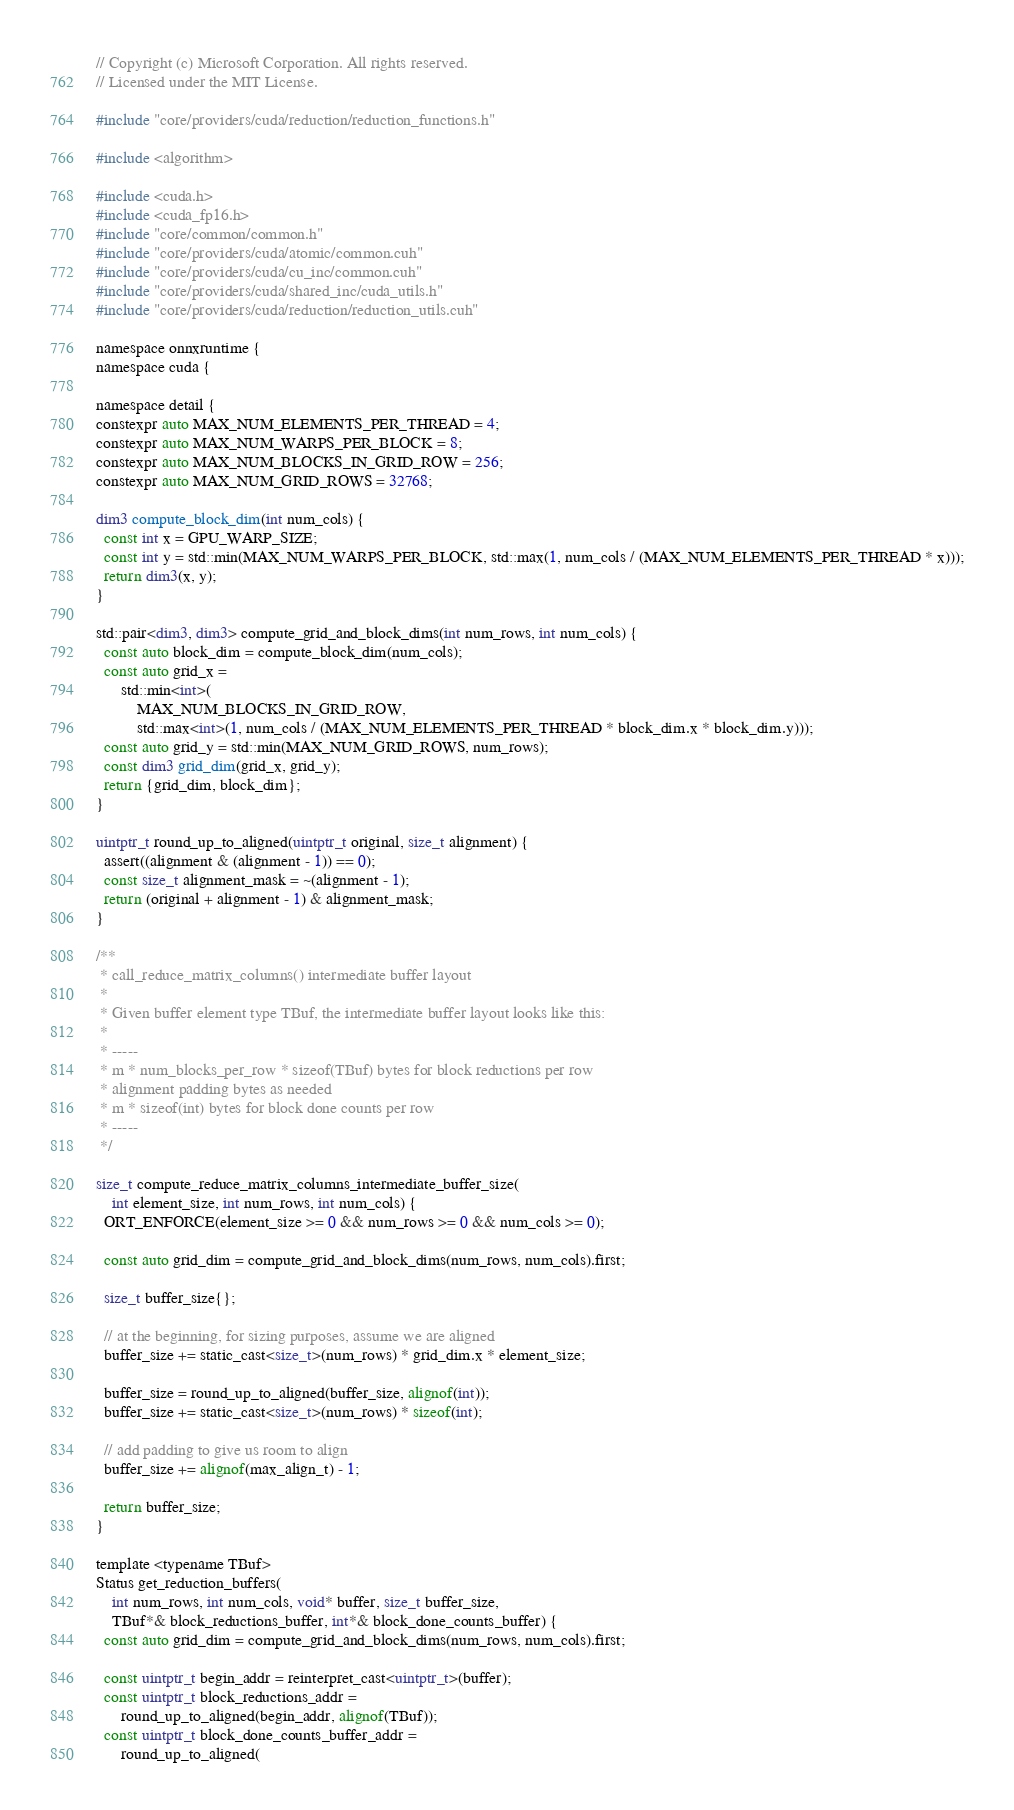Convert code to text. <code><loc_0><loc_0><loc_500><loc_500><_Cuda_>// Copyright (c) Microsoft Corporation. All rights reserved.
// Licensed under the MIT License.

#include "core/providers/cuda/reduction/reduction_functions.h"

#include <algorithm>

#include <cuda.h>
#include <cuda_fp16.h>
#include "core/common/common.h"
#include "core/providers/cuda/atomic/common.cuh"
#include "core/providers/cuda/cu_inc/common.cuh"
#include "core/providers/cuda/shared_inc/cuda_utils.h"
#include "core/providers/cuda/reduction/reduction_utils.cuh"

namespace onnxruntime {
namespace cuda {

namespace detail {
constexpr auto MAX_NUM_ELEMENTS_PER_THREAD = 4;
constexpr auto MAX_NUM_WARPS_PER_BLOCK = 8;
constexpr auto MAX_NUM_BLOCKS_IN_GRID_ROW = 256;
constexpr auto MAX_NUM_GRID_ROWS = 32768;

dim3 compute_block_dim(int num_cols) {
  const int x = GPU_WARP_SIZE;
  const int y = std::min(MAX_NUM_WARPS_PER_BLOCK, std::max(1, num_cols / (MAX_NUM_ELEMENTS_PER_THREAD * x)));
  return dim3(x, y);
}

std::pair<dim3, dim3> compute_grid_and_block_dims(int num_rows, int num_cols) {
  const auto block_dim = compute_block_dim(num_cols);
  const auto grid_x =
      std::min<int>(
          MAX_NUM_BLOCKS_IN_GRID_ROW,
          std::max<int>(1, num_cols / (MAX_NUM_ELEMENTS_PER_THREAD * block_dim.x * block_dim.y)));
  const auto grid_y = std::min(MAX_NUM_GRID_ROWS, num_rows);
  const dim3 grid_dim(grid_x, grid_y);
  return {grid_dim, block_dim};
}

uintptr_t round_up_to_aligned(uintptr_t original, size_t alignment) {
  assert((alignment & (alignment - 1)) == 0);
  const size_t alignment_mask = ~(alignment - 1);
  return (original + alignment - 1) & alignment_mask;
}

/**
 * call_reduce_matrix_columns() intermediate buffer layout
 *
 * Given buffer element type TBuf, the intermediate buffer layout looks like this:
 *
 * -----
 * m * num_blocks_per_row * sizeof(TBuf) bytes for block reductions per row
 * alignment padding bytes as needed
 * m * sizeof(int) bytes for block done counts per row
 * -----
 */

size_t compute_reduce_matrix_columns_intermediate_buffer_size(
    int element_size, int num_rows, int num_cols) {
  ORT_ENFORCE(element_size >= 0 && num_rows >= 0 && num_cols >= 0);

  const auto grid_dim = compute_grid_and_block_dims(num_rows, num_cols).first;

  size_t buffer_size{};

  // at the beginning, for sizing purposes, assume we are aligned
  buffer_size += static_cast<size_t>(num_rows) * grid_dim.x * element_size;

  buffer_size = round_up_to_aligned(buffer_size, alignof(int));
  buffer_size += static_cast<size_t>(num_rows) * sizeof(int);

  // add padding to give us room to align
  buffer_size += alignof(max_align_t) - 1;

  return buffer_size;
}

template <typename TBuf>
Status get_reduction_buffers(
    int num_rows, int num_cols, void* buffer, size_t buffer_size,
    TBuf*& block_reductions_buffer, int*& block_done_counts_buffer) {
  const auto grid_dim = compute_grid_and_block_dims(num_rows, num_cols).first;

  const uintptr_t begin_addr = reinterpret_cast<uintptr_t>(buffer);
  const uintptr_t block_reductions_addr =
      round_up_to_aligned(begin_addr, alignof(TBuf));
  const uintptr_t block_done_counts_buffer_addr =
      round_up_to_aligned(</code> 